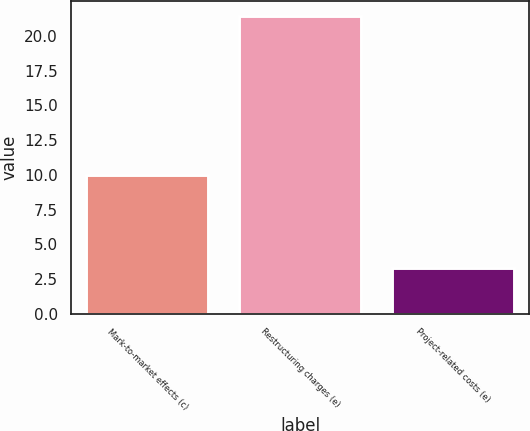<chart> <loc_0><loc_0><loc_500><loc_500><bar_chart><fcel>Mark-to-market effects (c)<fcel>Restructuring charges (e)<fcel>Project-related costs (e)<nl><fcel>10<fcel>21.4<fcel>3.3<nl></chart> 